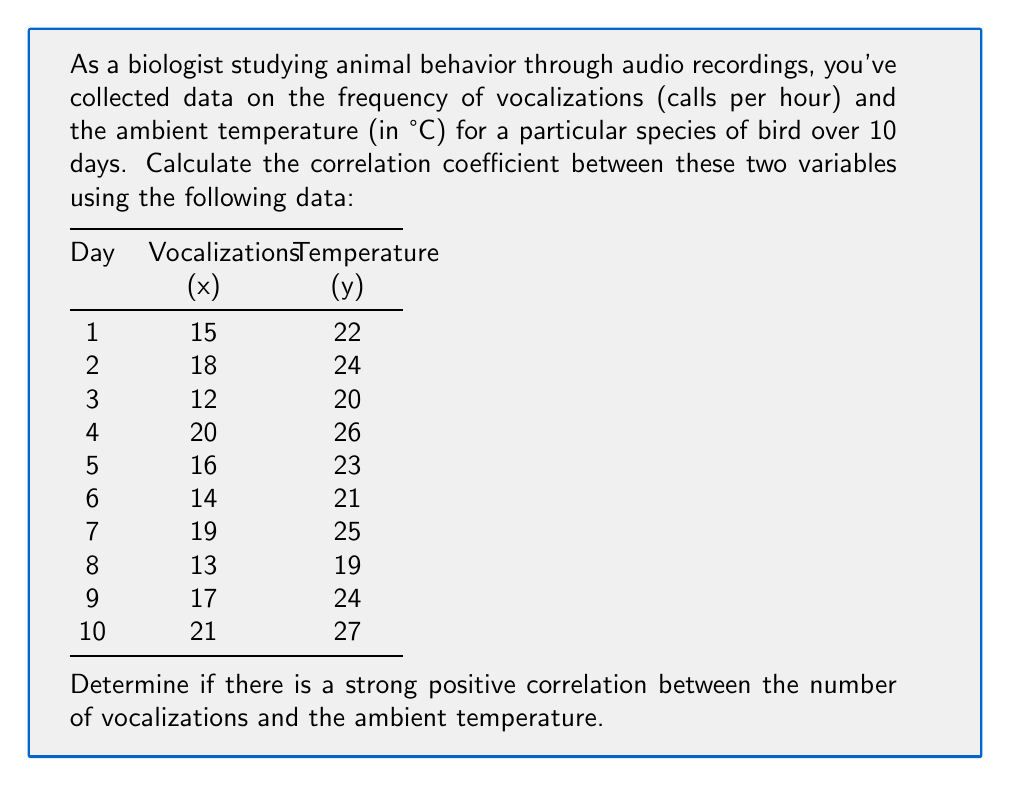Help me with this question. To calculate the correlation coefficient (r) between two variables, we use the formula:

$$ r = \frac{n\sum xy - (\sum x)(\sum y)}{\sqrt{[n\sum x^2 - (\sum x)^2][n\sum y^2 - (\sum y)^2]}} $$

Where:
n = number of pairs of data
x = vocalizations per hour
y = temperature in °C

Step 1: Calculate the required sums and squares:
$\sum x = 165$
$\sum y = 231$
$\sum xy = 3,845$
$\sum x^2 = 2,805$
$\sum y^2 = 5,371$

Step 2: Apply the formula:

$$ r = \frac{10(3,845) - (165)(231)}{\sqrt{[10(2,805) - 165^2][10(5,371) - 231^2]}} $$

Step 3: Simplify:

$$ r = \frac{38,450 - 38,115}{\sqrt{(28,050 - 27,225)(53,710 - 53,361)}} $$

$$ r = \frac{335}{\sqrt{(825)(349)}} $$

$$ r = \frac{335}{\sqrt{287,925}} $$

$$ r = \frac{335}{536.59} $$

$$ r \approx 0.6243 $$

Step 4: Interpret the result:
The correlation coefficient ranges from -1 to 1, where:
- Values close to 1 indicate a strong positive correlation
- Values close to -1 indicate a strong negative correlation
- Values close to 0 indicate little to no linear correlation

A correlation coefficient of 0.6243 suggests a moderately strong positive correlation between the number of vocalizations and the ambient temperature.
Answer: The correlation coefficient is approximately 0.6243, indicating a moderately strong positive correlation between the number of vocalizations and the ambient temperature. 